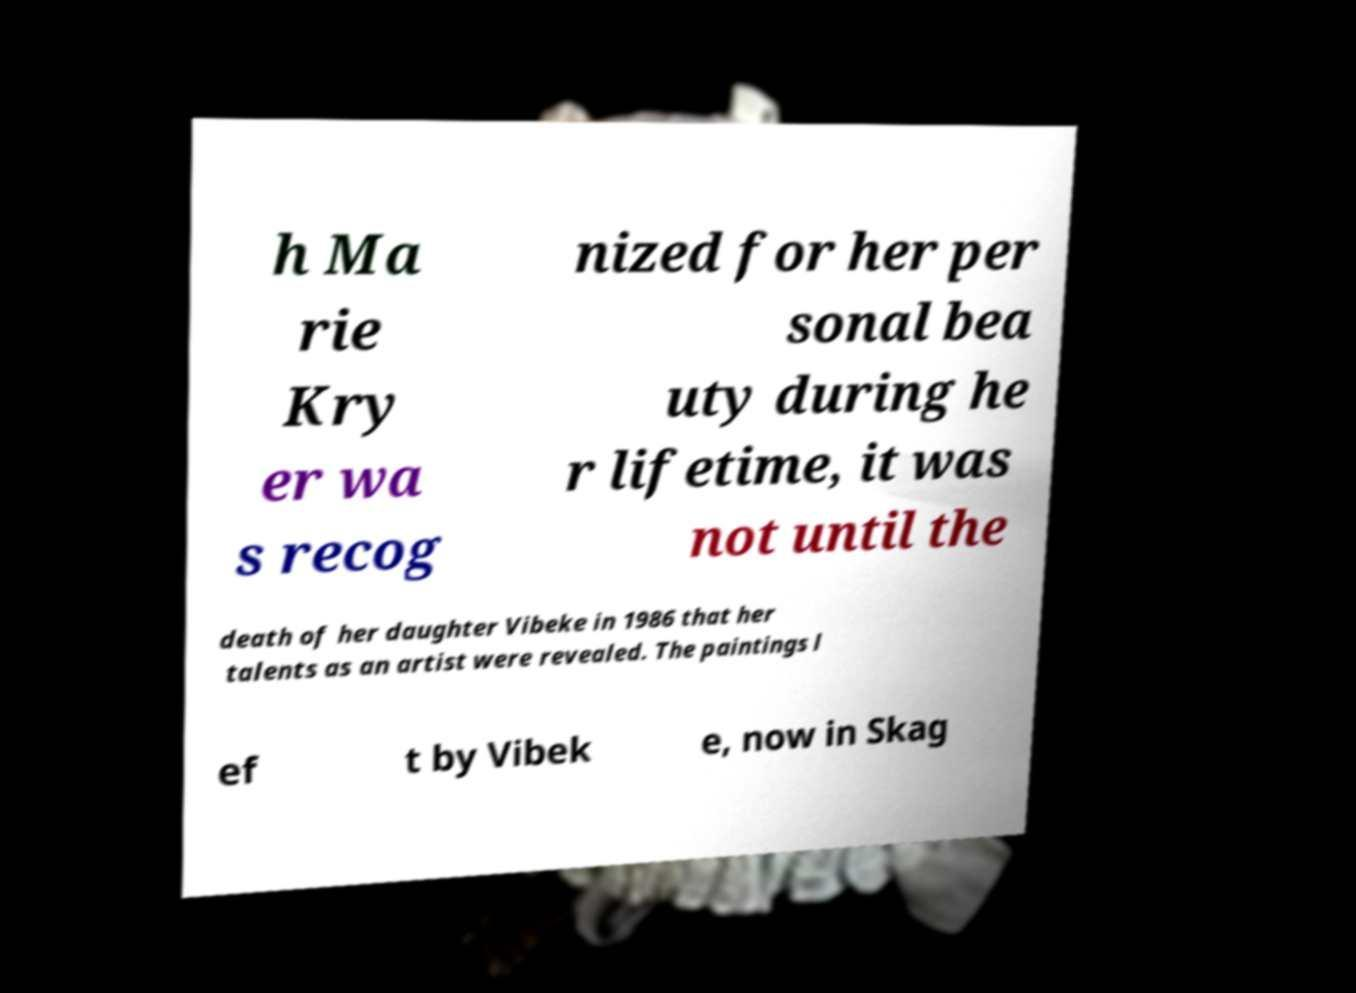For documentation purposes, I need the text within this image transcribed. Could you provide that? h Ma rie Kry er wa s recog nized for her per sonal bea uty during he r lifetime, it was not until the death of her daughter Vibeke in 1986 that her talents as an artist were revealed. The paintings l ef t by Vibek e, now in Skag 